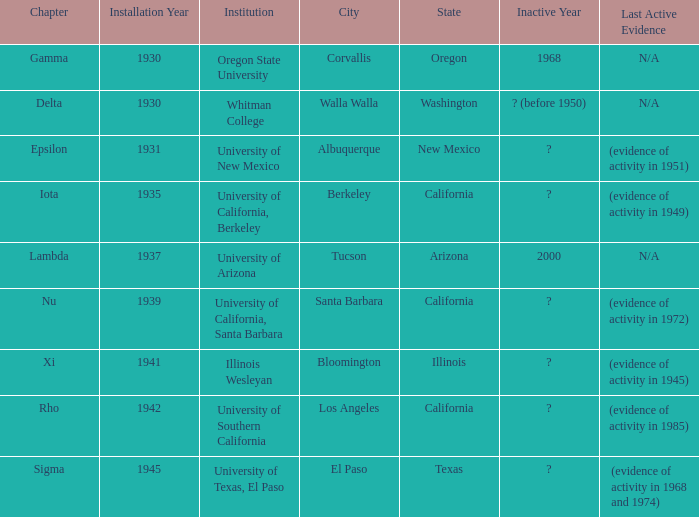What does the inactive state for University of Texas, El Paso?  ? (evidence of activity in 1968 and 1974). 